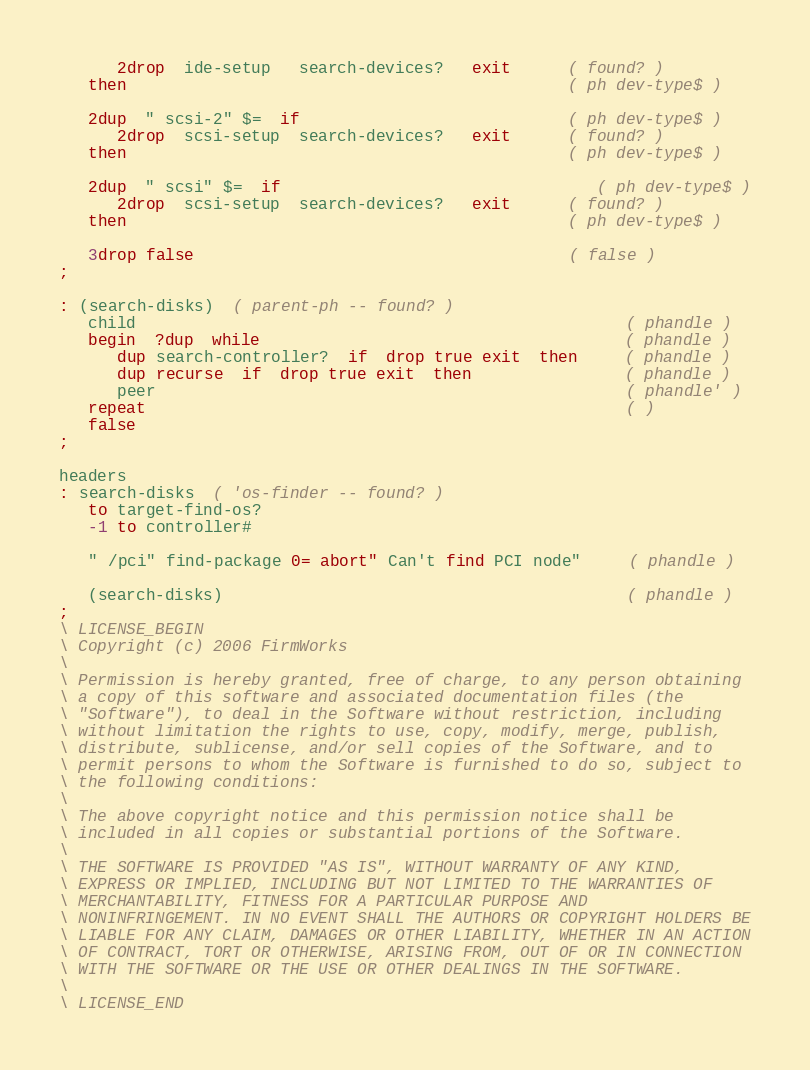<code> <loc_0><loc_0><loc_500><loc_500><_Forth_>      2drop  ide-setup   search-devices?   exit      ( found? )
   then                                              ( ph dev-type$ )

   2dup  " scsi-2" $=  if                            ( ph dev-type$ )
      2drop  scsi-setup  search-devices?   exit      ( found? )
   then                                              ( ph dev-type$ )

   2dup  " scsi" $=  if	                             ( ph dev-type$ )
      2drop  scsi-setup  search-devices?   exit      ( found? )
   then                                              ( ph dev-type$ )

   3drop false                                       ( false )
;

: (search-disks)  ( parent-ph -- found? )
   child                                                   ( phandle ) 
   begin  ?dup  while                                      ( phandle )
      dup search-controller?  if  drop true exit  then     ( phandle )
      dup recurse  if  drop true exit  then                ( phandle )
      peer                                                 ( phandle' )
   repeat                                                  ( )
   false
;

headers
: search-disks  ( 'os-finder -- found? )
   to target-find-os?
   -1 to controller#

   " /pci" find-package 0= abort" Can't find PCI node"     ( phandle )

   (search-disks)                                          ( phandle )
;
\ LICENSE_BEGIN
\ Copyright (c) 2006 FirmWorks
\ 
\ Permission is hereby granted, free of charge, to any person obtaining
\ a copy of this software and associated documentation files (the
\ "Software"), to deal in the Software without restriction, including
\ without limitation the rights to use, copy, modify, merge, publish,
\ distribute, sublicense, and/or sell copies of the Software, and to
\ permit persons to whom the Software is furnished to do so, subject to
\ the following conditions:
\ 
\ The above copyright notice and this permission notice shall be
\ included in all copies or substantial portions of the Software.
\ 
\ THE SOFTWARE IS PROVIDED "AS IS", WITHOUT WARRANTY OF ANY KIND,
\ EXPRESS OR IMPLIED, INCLUDING BUT NOT LIMITED TO THE WARRANTIES OF
\ MERCHANTABILITY, FITNESS FOR A PARTICULAR PURPOSE AND
\ NONINFRINGEMENT. IN NO EVENT SHALL THE AUTHORS OR COPYRIGHT HOLDERS BE
\ LIABLE FOR ANY CLAIM, DAMAGES OR OTHER LIABILITY, WHETHER IN AN ACTION
\ OF CONTRACT, TORT OR OTHERWISE, ARISING FROM, OUT OF OR IN CONNECTION
\ WITH THE SOFTWARE OR THE USE OR OTHER DEALINGS IN THE SOFTWARE.
\
\ LICENSE_END
</code> 